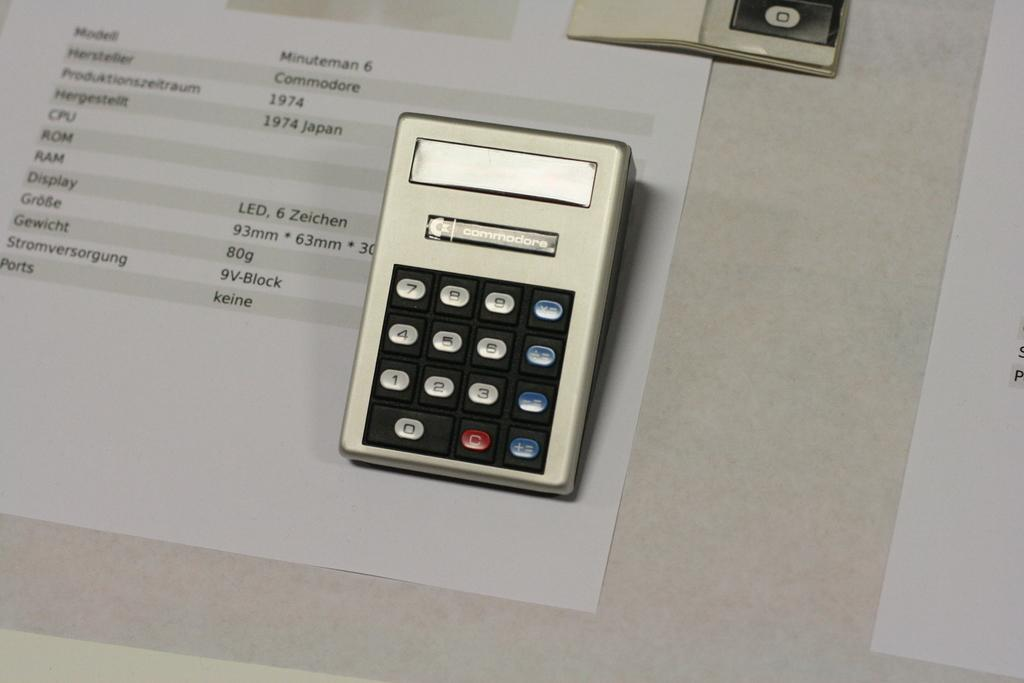What device is visible in the image? There is a calculator in the image. Where is the calculator located? The calculator is placed on a table. What else can be seen on the table in the image? There are papers on the table in the image. What type of development can be seen in the image? There is no development visible in the image; it only features a calculator placed on a table with papers. Can you describe the mist in the image? There is no mist present in the image. 